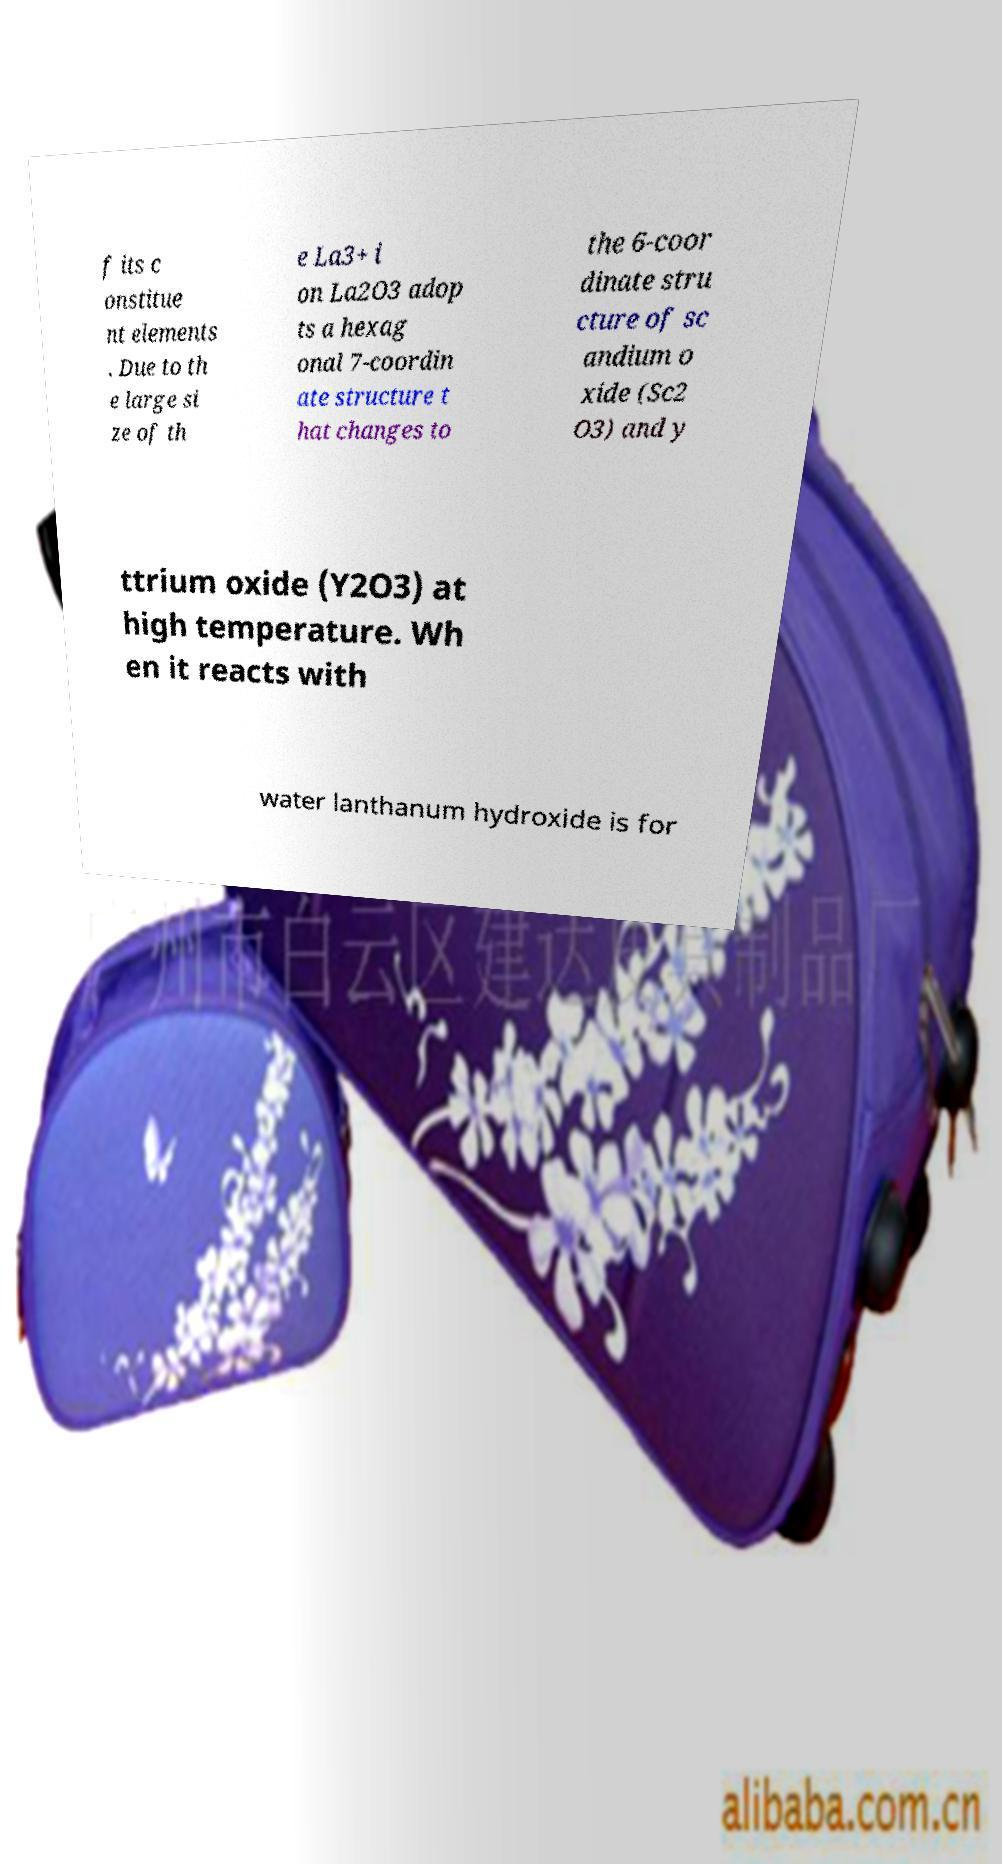What messages or text are displayed in this image? I need them in a readable, typed format. f its c onstitue nt elements . Due to th e large si ze of th e La3+ i on La2O3 adop ts a hexag onal 7-coordin ate structure t hat changes to the 6-coor dinate stru cture of sc andium o xide (Sc2 O3) and y ttrium oxide (Y2O3) at high temperature. Wh en it reacts with water lanthanum hydroxide is for 